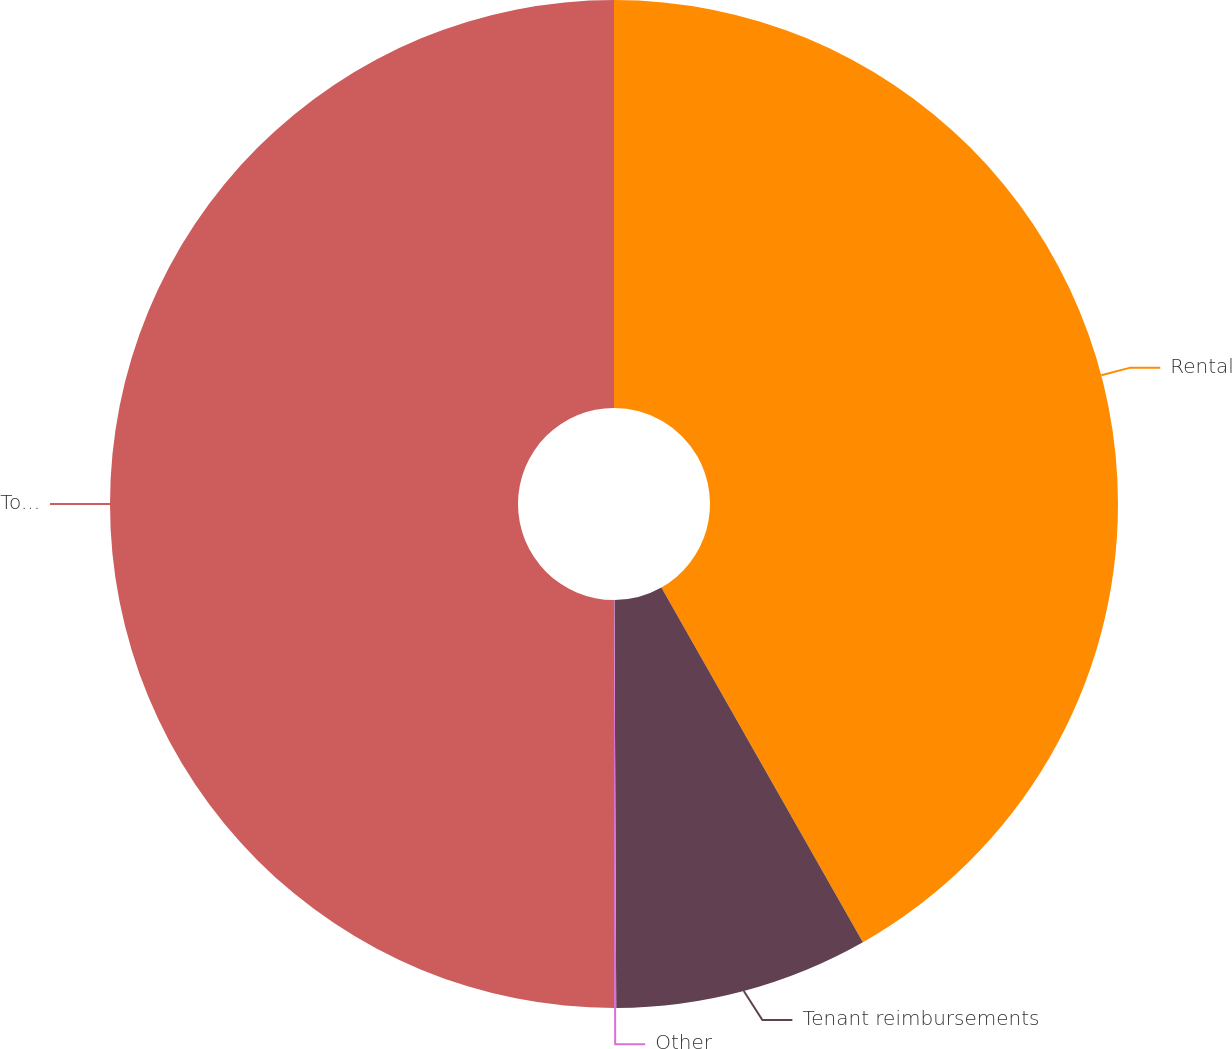<chart> <loc_0><loc_0><loc_500><loc_500><pie_chart><fcel>Rental<fcel>Tenant reimbursements<fcel>Other<fcel>Total operating revenues<nl><fcel>41.78%<fcel>8.15%<fcel>0.07%<fcel>50.0%<nl></chart> 